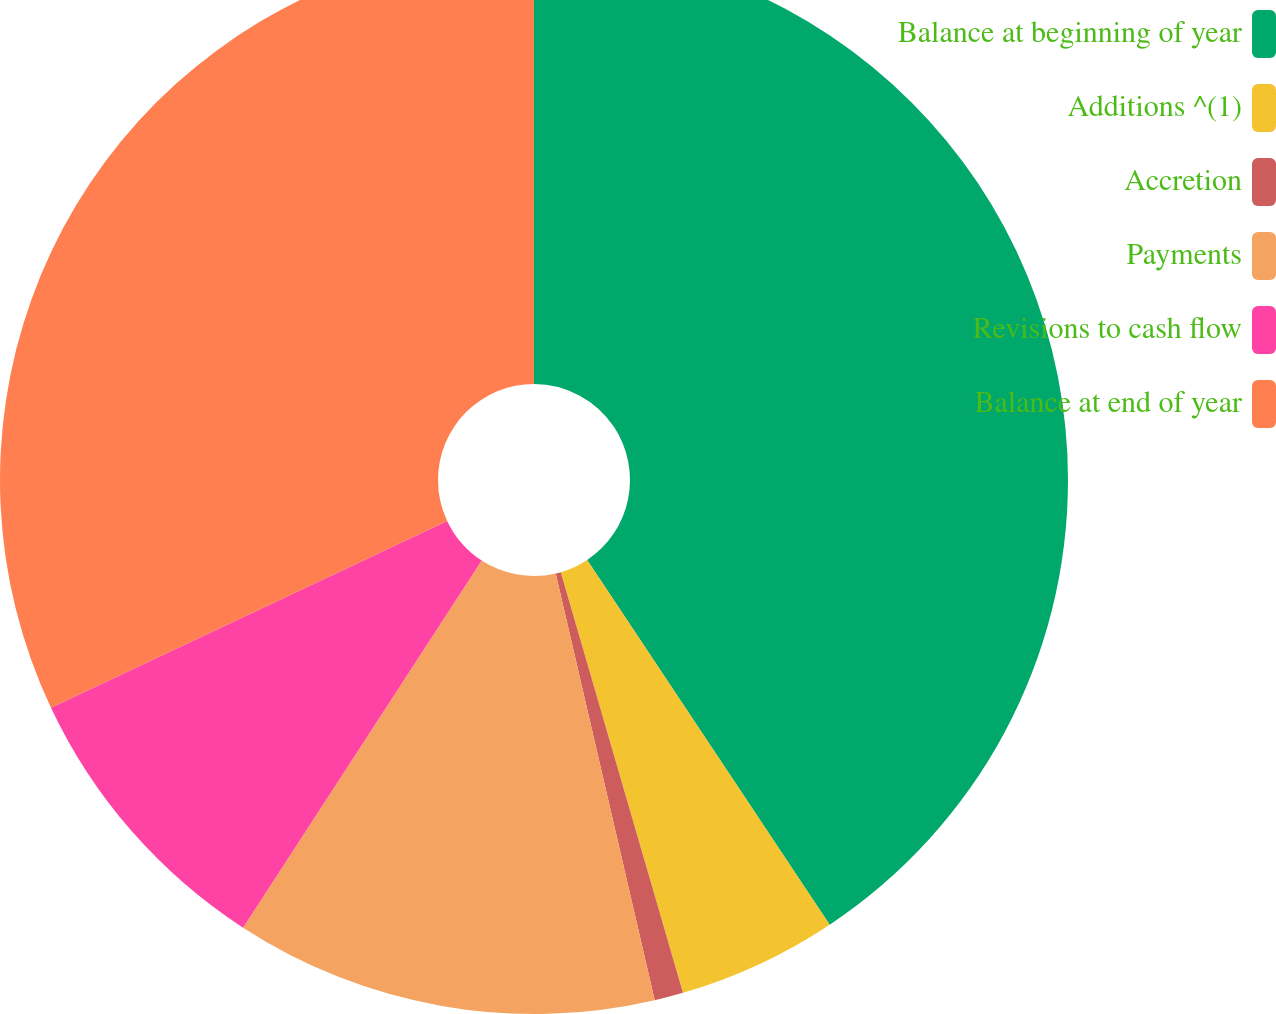<chart> <loc_0><loc_0><loc_500><loc_500><pie_chart><fcel>Balance at beginning of year<fcel>Additions ^(1)<fcel>Accretion<fcel>Payments<fcel>Revisions to cash flow<fcel>Balance at end of year<nl><fcel>40.66%<fcel>4.84%<fcel>0.87%<fcel>12.8%<fcel>8.82%<fcel>32.01%<nl></chart> 